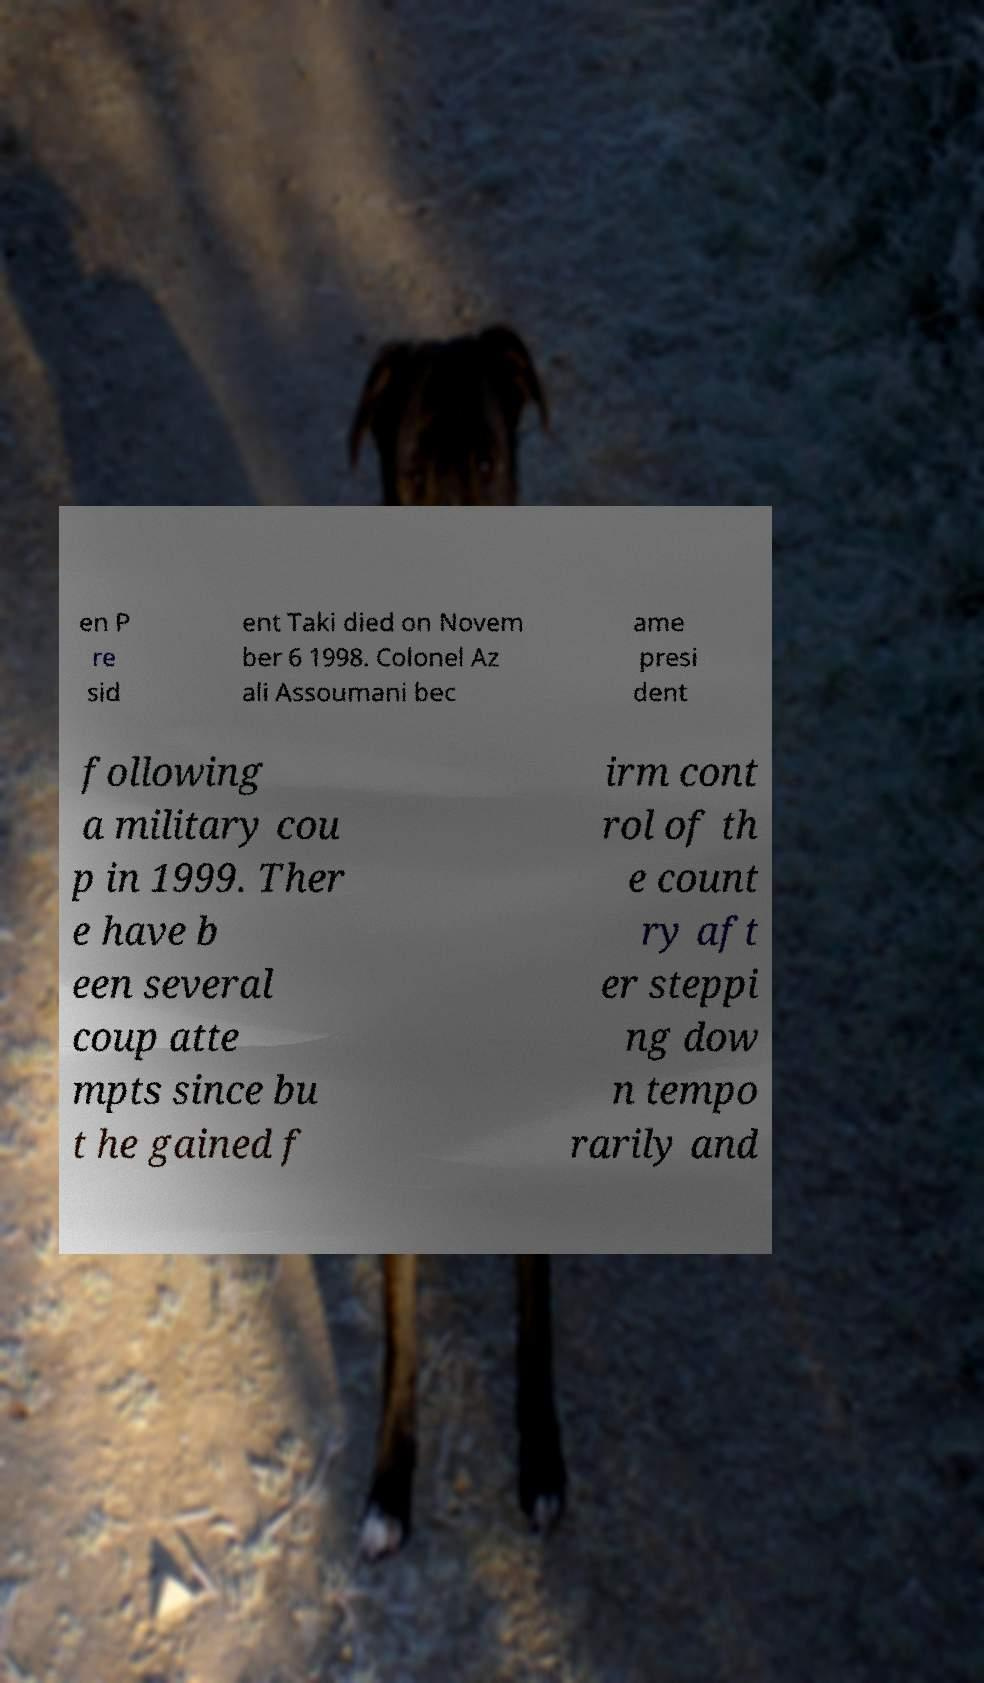Please read and relay the text visible in this image. What does it say? en P re sid ent Taki died on Novem ber 6 1998. Colonel Az ali Assoumani bec ame presi dent following a military cou p in 1999. Ther e have b een several coup atte mpts since bu t he gained f irm cont rol of th e count ry aft er steppi ng dow n tempo rarily and 